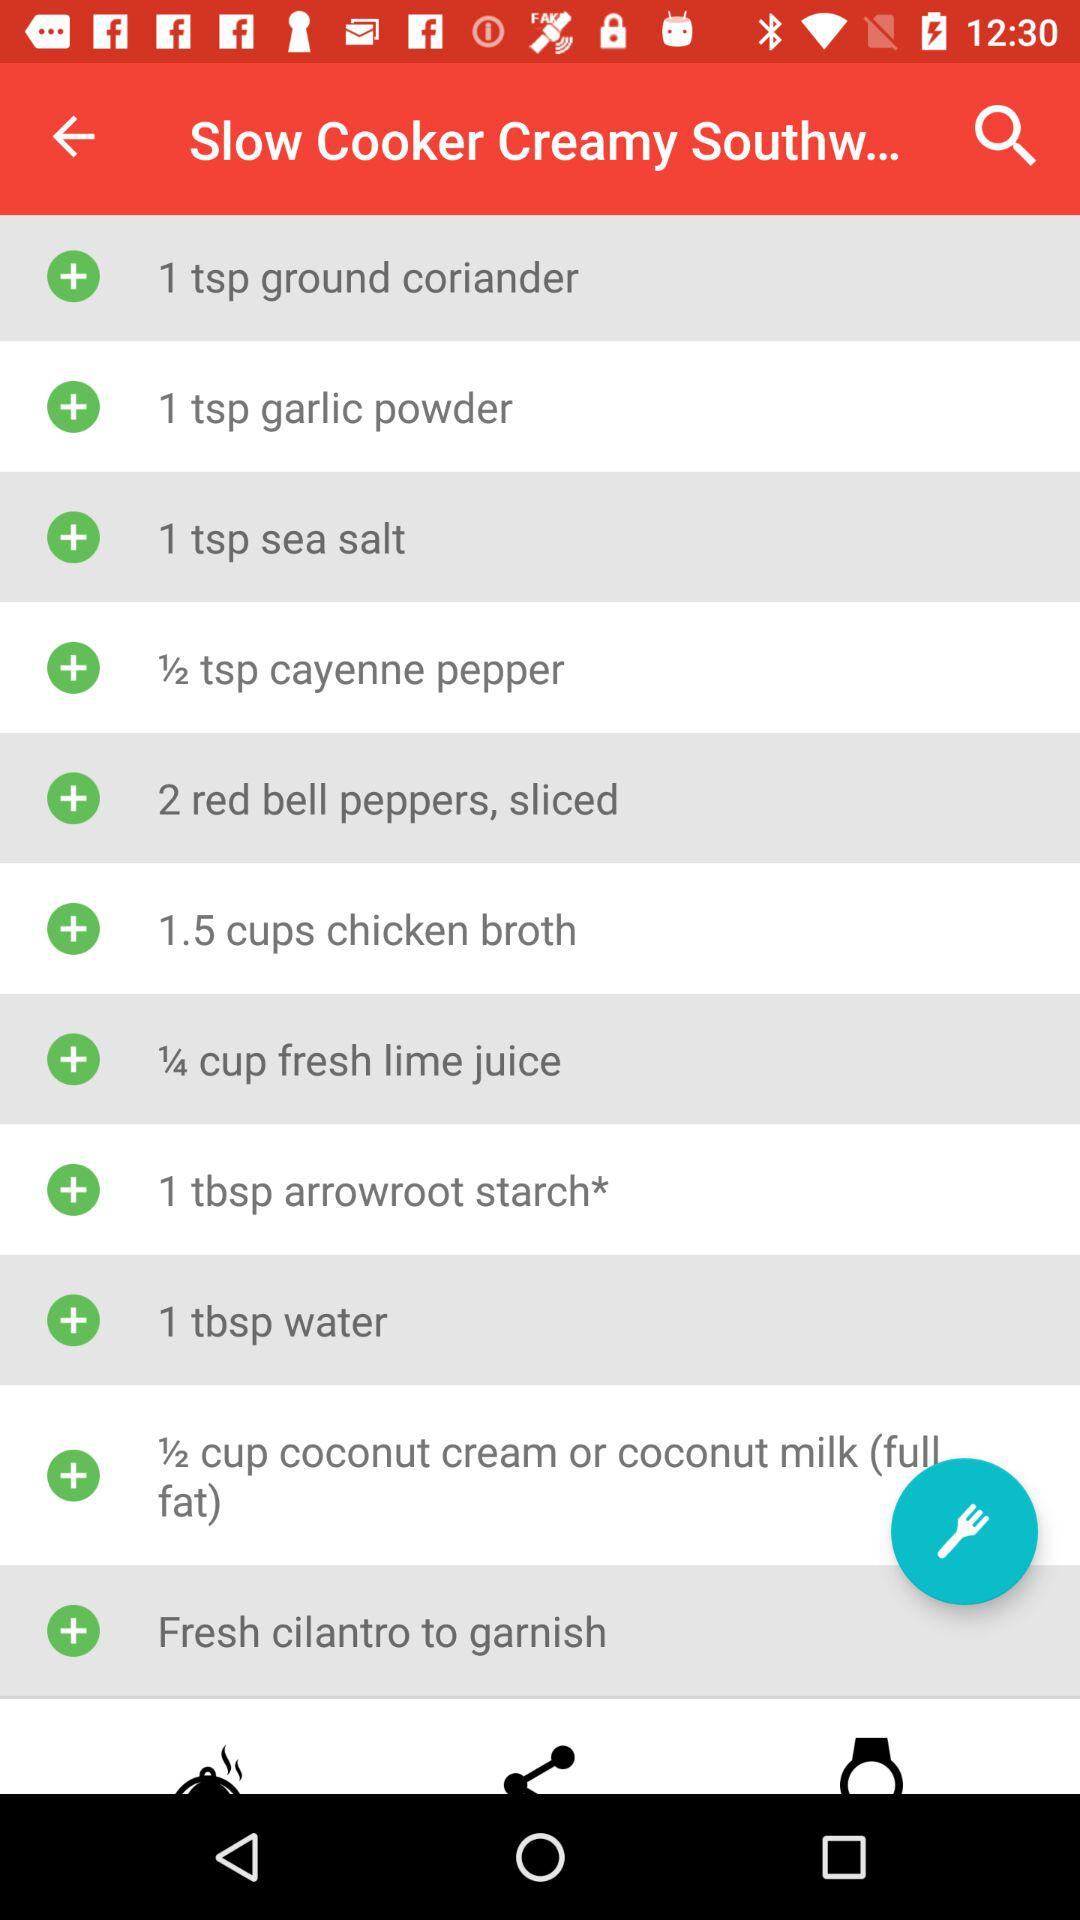How much fresh lime juice is required? The required quantity of fresh lime juice is ¼ cup. 